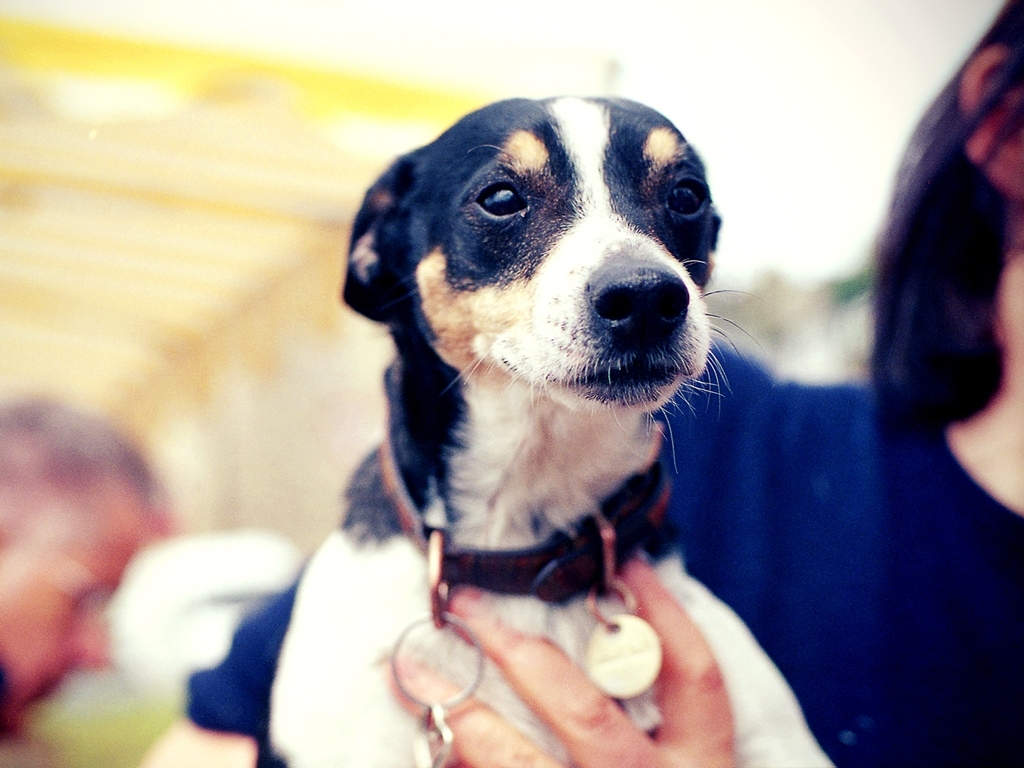Are there any quality issues with this image? The photograph exhibits a soft focus, particularly around the dog's face, and mild overexposure in the background which detracts from the image's overall clarity. 